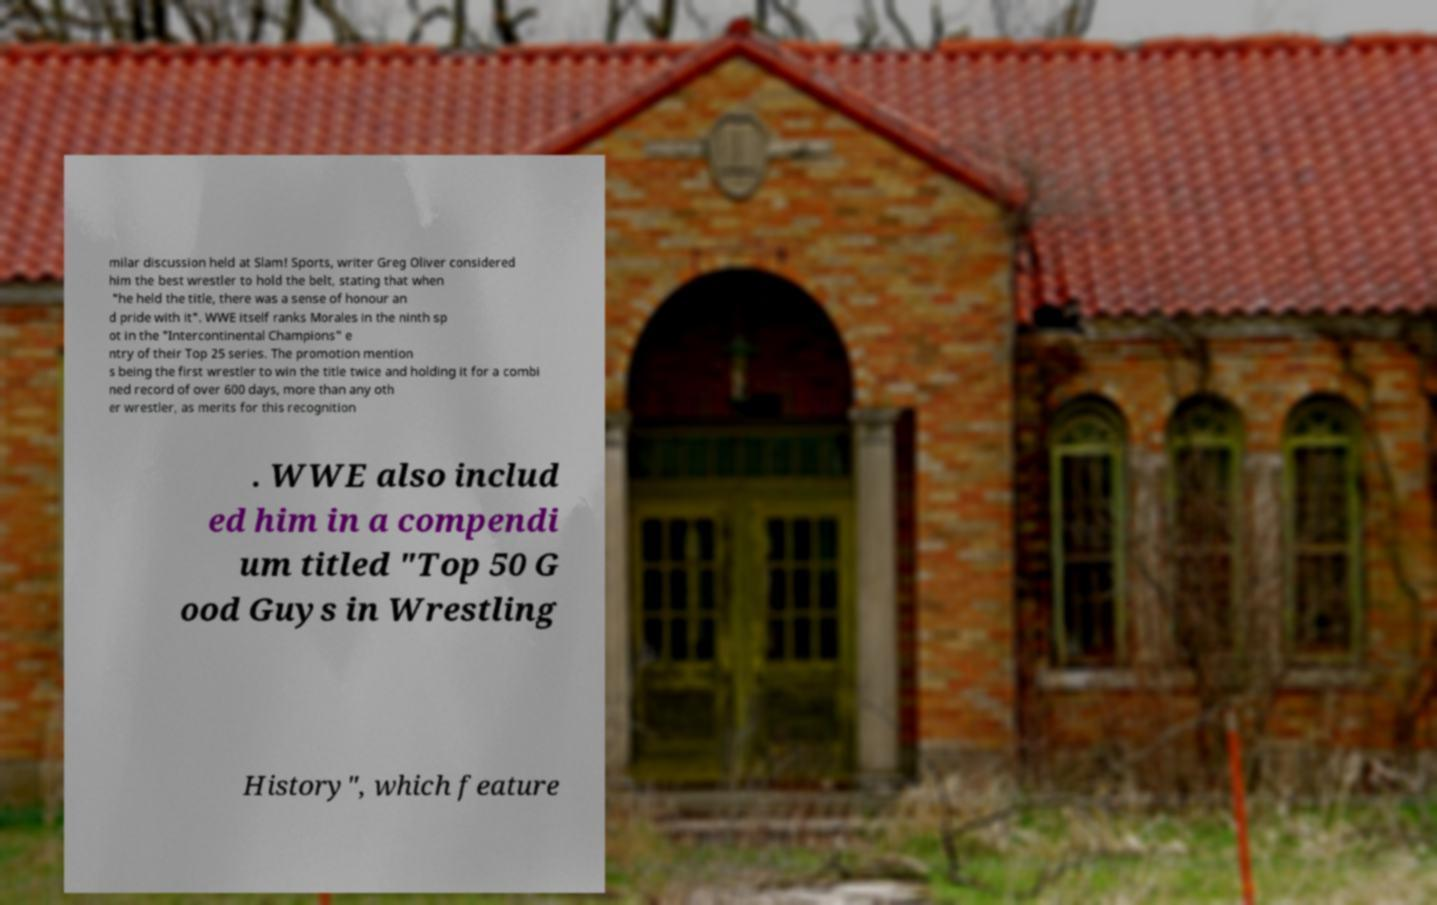Please read and relay the text visible in this image. What does it say? milar discussion held at Slam! Sports, writer Greg Oliver considered him the best wrestler to hold the belt, stating that when "he held the title, there was a sense of honour an d pride with it". WWE itself ranks Morales in the ninth sp ot in the "Intercontinental Champions" e ntry of their Top 25 series. The promotion mention s being the first wrestler to win the title twice and holding it for a combi ned record of over 600 days, more than any oth er wrestler, as merits for this recognition . WWE also includ ed him in a compendi um titled "Top 50 G ood Guys in Wrestling History", which feature 